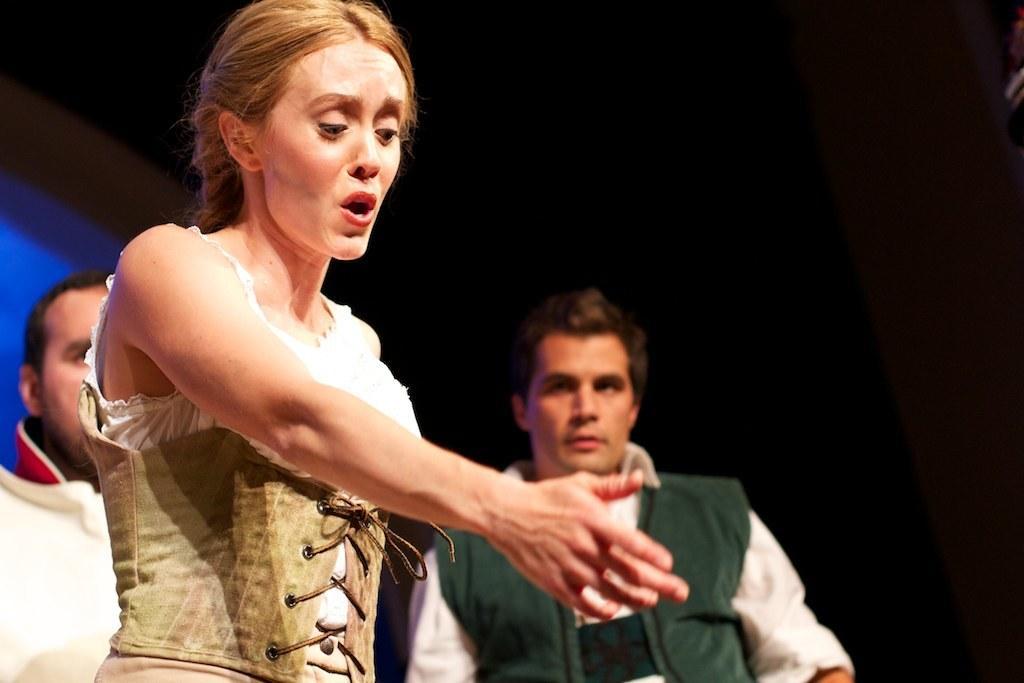In one or two sentences, can you explain what this image depicts? In this image there are two men and a woman standing. The woman is stretching her hand out. Behind them the background is dark. 